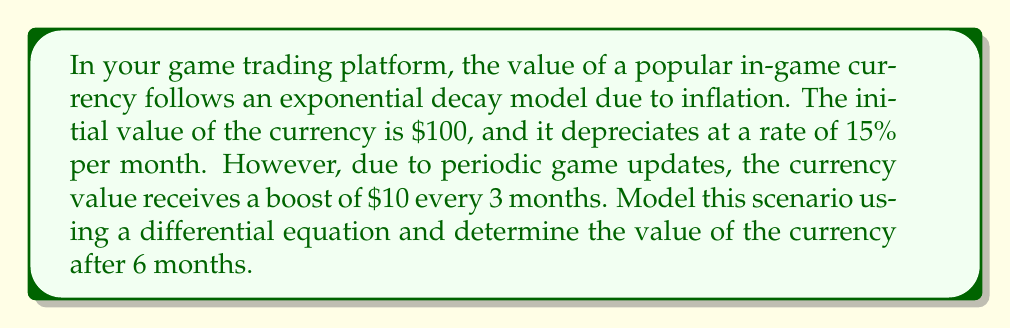Teach me how to tackle this problem. Let's approach this step-by-step:

1) First, we need to set up our differential equation. Let $V(t)$ be the value of the currency at time $t$ (in months).

2) The exponential decay is modeled by the equation:
   $$\frac{dV}{dt} = -kV$$
   where $k$ is the decay constant.

3) Given the 15% monthly depreciation rate, we can calculate $k$:
   $$k = -\ln(1-0.15) \approx 0.1625$$

4) Now, our differential equation becomes:
   $$\frac{dV}{dt} = -0.1625V$$

5) To account for the periodic boosts, we add a pulse function:
   $$\frac{dV}{dt} = -0.1625V + 10\sum_{n=0}^{\infty}\delta(t-3n)$$
   where $\delta(t)$ is the Dirac delta function.

6) The solution to this equation is:
   $$V(t) = V_0e^{-0.1625t} + 10\sum_{n=0}^{\lfloor t/3 \rfloor}e^{-0.1625(t-3n)}$$
   where $V_0 = 100$ is the initial value and $\lfloor t/3 \rfloor$ is the floor function.

7) After 6 months, we have:
   $$V(6) = 100e^{-0.1625(6)} + 10e^{-0.1625(6)} + 10e^{-0.1625(3)}$$

8) Calculating this:
   $$V(6) \approx 37.51 + 3.75 + 6.06 = 47.32$$

Therefore, the value of the currency after 6 months is approximately $47.32.
Answer: $47.32 